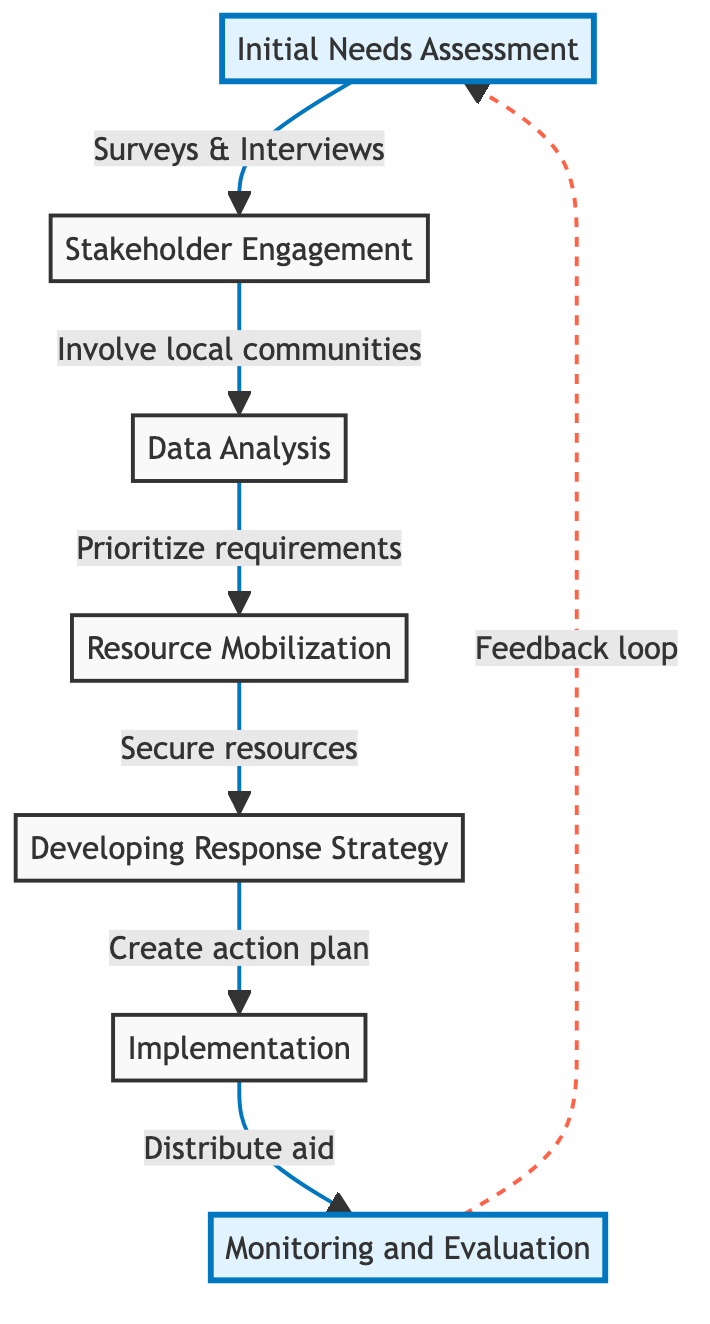What is the first step in the flowchart? The first step in the flowchart is indicated by the starting node. In this diagram, the first node is "Initial Needs Assessment."
Answer: Initial Needs Assessment How many steps are there in total? To find the total number of steps, we count the nodes in the diagram. There are seven distinct steps listed.
Answer: 7 Which step follows "Data Analysis"? According to the directional arrows in the diagram, "Resource Mobilization" is the step that follows "Data Analysis."
Answer: Resource Mobilization What action is taken after "Implementation"? The flowchart shows that after "Implementation," the next step is "Monitoring and Evaluation."
Answer: Monitoring and Evaluation What type of engagement is emphasized in the second step? The second step is "Stakeholder Engagement," which emphasizes involving local communities, NGOs, and government agencies.
Answer: Involve local communities Which step includes the creation of a strategic action plan? The step that includes the creation of a strategic action plan is "Developing Response Strategy."
Answer: Developing Response Strategy What is identified in the "Resource Mobilization" step? In the "Resource Mobilization" step, the focus is on identifying and securing financial and material resources.
Answer: Secure resources What kind of loop is indicated after the "Monitoring and Evaluation" step? The diagram shows a feedback loop from "Monitoring and Evaluation" back to "Initial Needs Assessment," indicating continual improvement.
Answer: Feedback loop What is a key task during the "Initial Needs Assessment"? A key task during the "Initial Needs Assessment" is to conduct surveys and interviews with affected populations.
Answer: Conduct surveys and interviews 